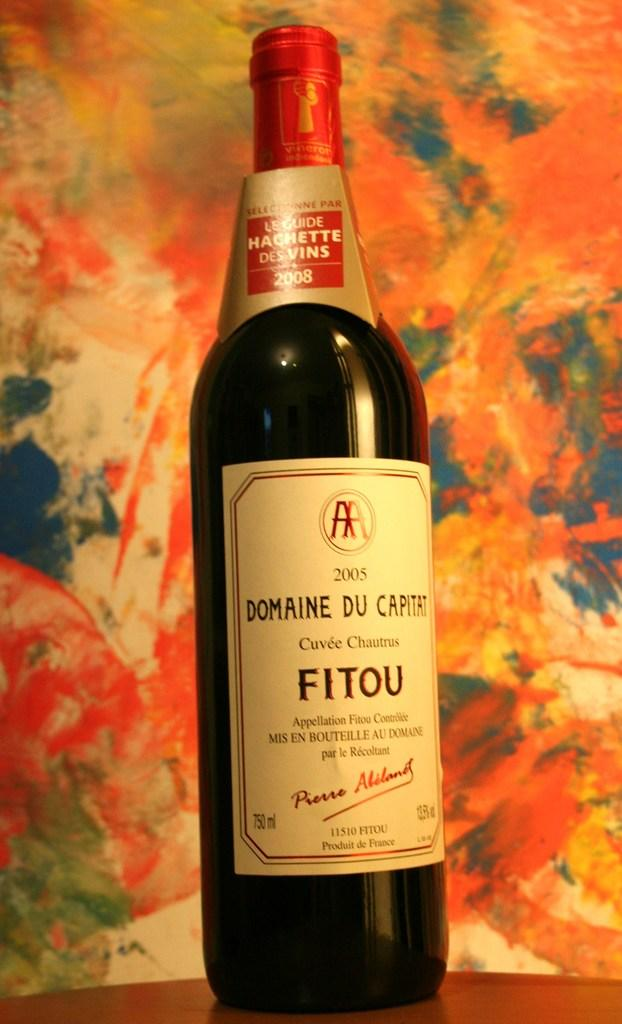<image>
Summarize the visual content of the image. A bottle of wine with Fitou written on the label. 